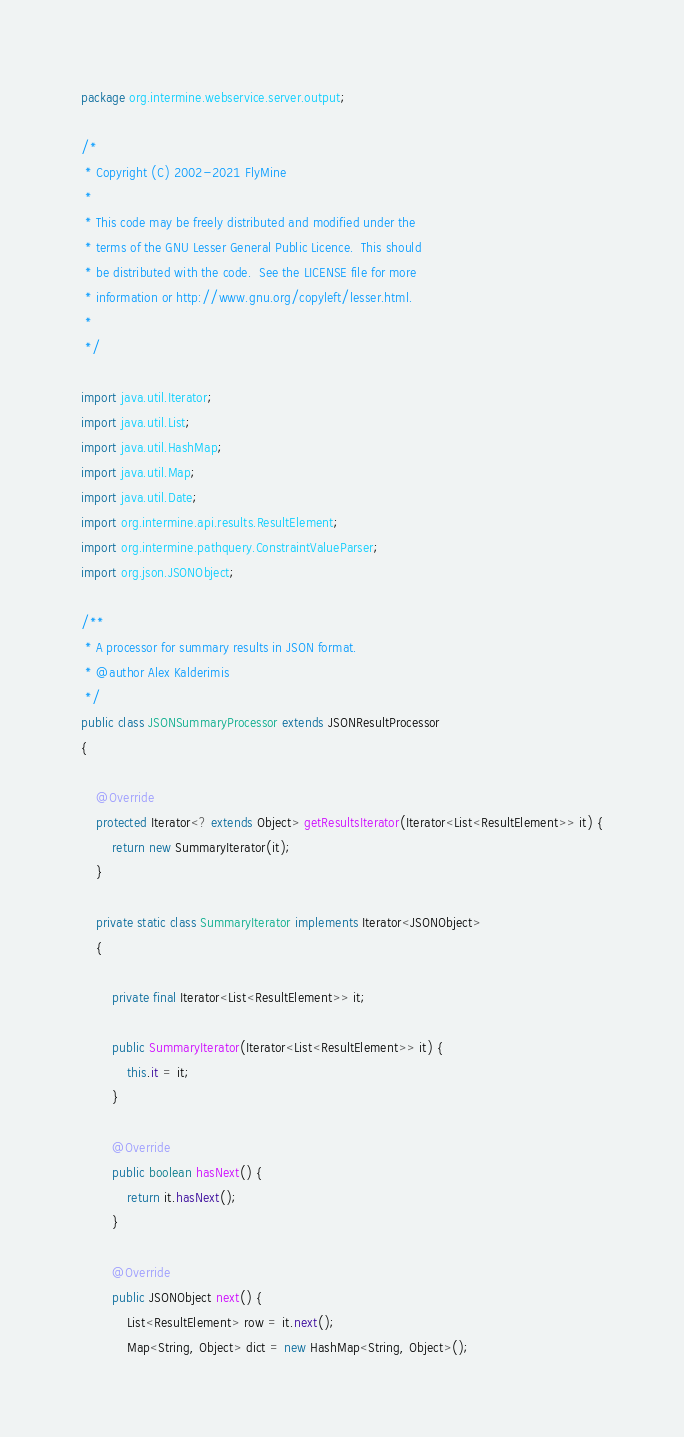Convert code to text. <code><loc_0><loc_0><loc_500><loc_500><_Java_>package org.intermine.webservice.server.output;

/*
 * Copyright (C) 2002-2021 FlyMine
 *
 * This code may be freely distributed and modified under the
 * terms of the GNU Lesser General Public Licence.  This should
 * be distributed with the code.  See the LICENSE file for more
 * information or http://www.gnu.org/copyleft/lesser.html.
 *
 */

import java.util.Iterator;
import java.util.List;
import java.util.HashMap;
import java.util.Map;
import java.util.Date;
import org.intermine.api.results.ResultElement;
import org.intermine.pathquery.ConstraintValueParser;
import org.json.JSONObject;

/**
 * A processor for summary results in JSON format.
 * @author Alex Kalderimis
 */
public class JSONSummaryProcessor extends JSONResultProcessor
{

    @Override
    protected Iterator<? extends Object> getResultsIterator(Iterator<List<ResultElement>> it) {
        return new SummaryIterator(it);
    }

    private static class SummaryIterator implements Iterator<JSONObject>
    {

        private final Iterator<List<ResultElement>> it;

        public SummaryIterator(Iterator<List<ResultElement>> it) {
            this.it = it;
        }

        @Override
        public boolean hasNext() {
            return it.hasNext();
        }

        @Override
        public JSONObject next() {
            List<ResultElement> row = it.next();
            Map<String, Object> dict = new HashMap<String, Object>();</code> 